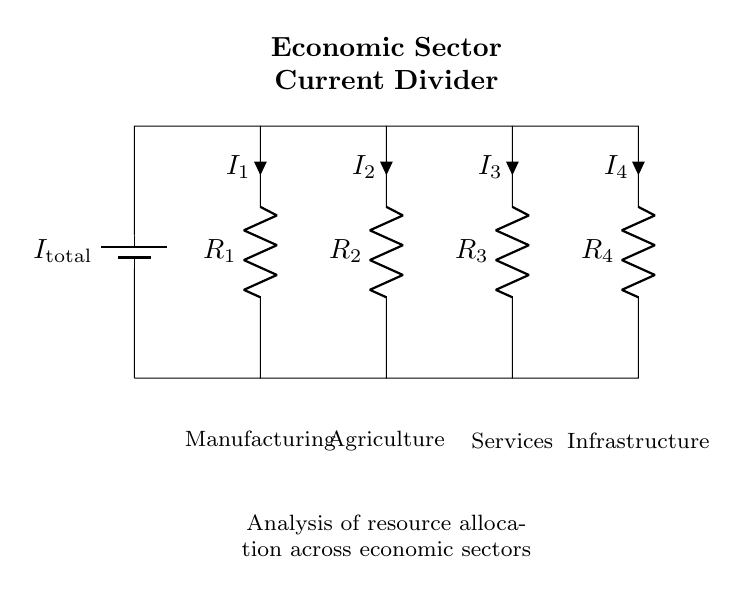What does each resistor represent? Each resistor in the circuit represents a different economic sector, where R1 corresponds to Manufacturing, R2 to Agriculture, R3 to Services, and R4 to Infrastructure.
Answer: Manufacturing, Agriculture, Services, Infrastructure What is the total current in the circuit? The total current, indicated as I_total, is the sum of the currents flowing through all branches which depend on the individual branch currents. This current is not numerically defined in the diagram but is a placeholder for a given total current value.
Answer: I_total Which economic sector has the highest current flow? The sector with the highest current flow is determined by comparing the individual branch currents marked as I1, I2, I3, and I4 by their respective resistor values. The sector with the lowest resistance will have the highest current according to Ohm's law.
Answer: Depends on resistance values How does resistance affect current distribution in the circuit? The current distribution across the branches is inversely proportional to their resistances; lower resistance results in higher current flow, meaning sectors with greater financial resources can effectively allocate more current to enhance productivity and growth.
Answer: Inversely proportional What is the relationship between current and resource allocation? The current flowing through each branch represents the allocation of resources to each sector; a higher current indicates a greater allocation of resources, which can impact economic growth in that sector.
Answer: Proportional allocation 